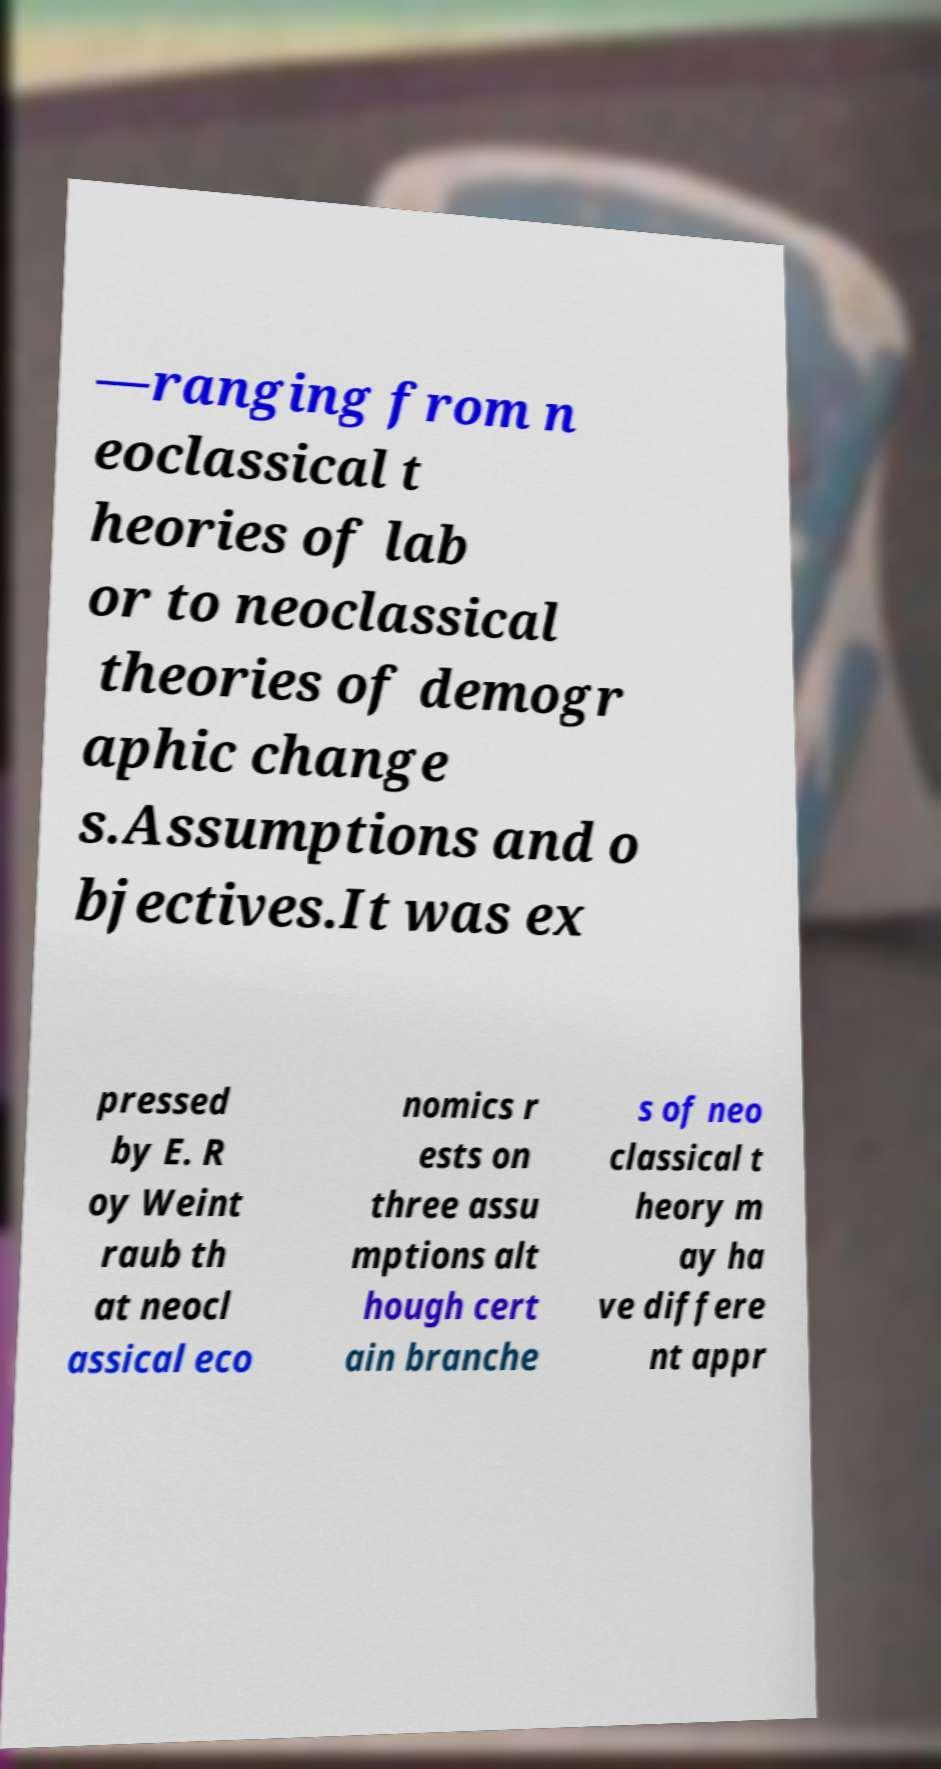There's text embedded in this image that I need extracted. Can you transcribe it verbatim? —ranging from n eoclassical t heories of lab or to neoclassical theories of demogr aphic change s.Assumptions and o bjectives.It was ex pressed by E. R oy Weint raub th at neocl assical eco nomics r ests on three assu mptions alt hough cert ain branche s of neo classical t heory m ay ha ve differe nt appr 